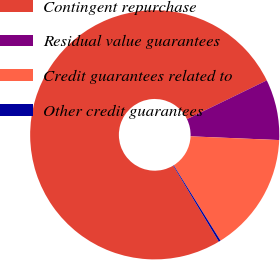<chart> <loc_0><loc_0><loc_500><loc_500><pie_chart><fcel>Contingent repurchase<fcel>Residual value guarantees<fcel>Credit guarantees related to<fcel>Other credit guarantees<nl><fcel>76.4%<fcel>7.87%<fcel>15.48%<fcel>0.25%<nl></chart> 